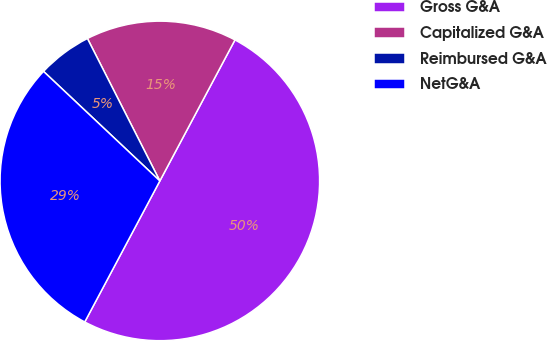Convert chart. <chart><loc_0><loc_0><loc_500><loc_500><pie_chart><fcel>Gross G&A<fcel>Capitalized G&A<fcel>Reimbursed G&A<fcel>NetG&A<nl><fcel>50.0%<fcel>15.28%<fcel>5.49%<fcel>29.24%<nl></chart> 